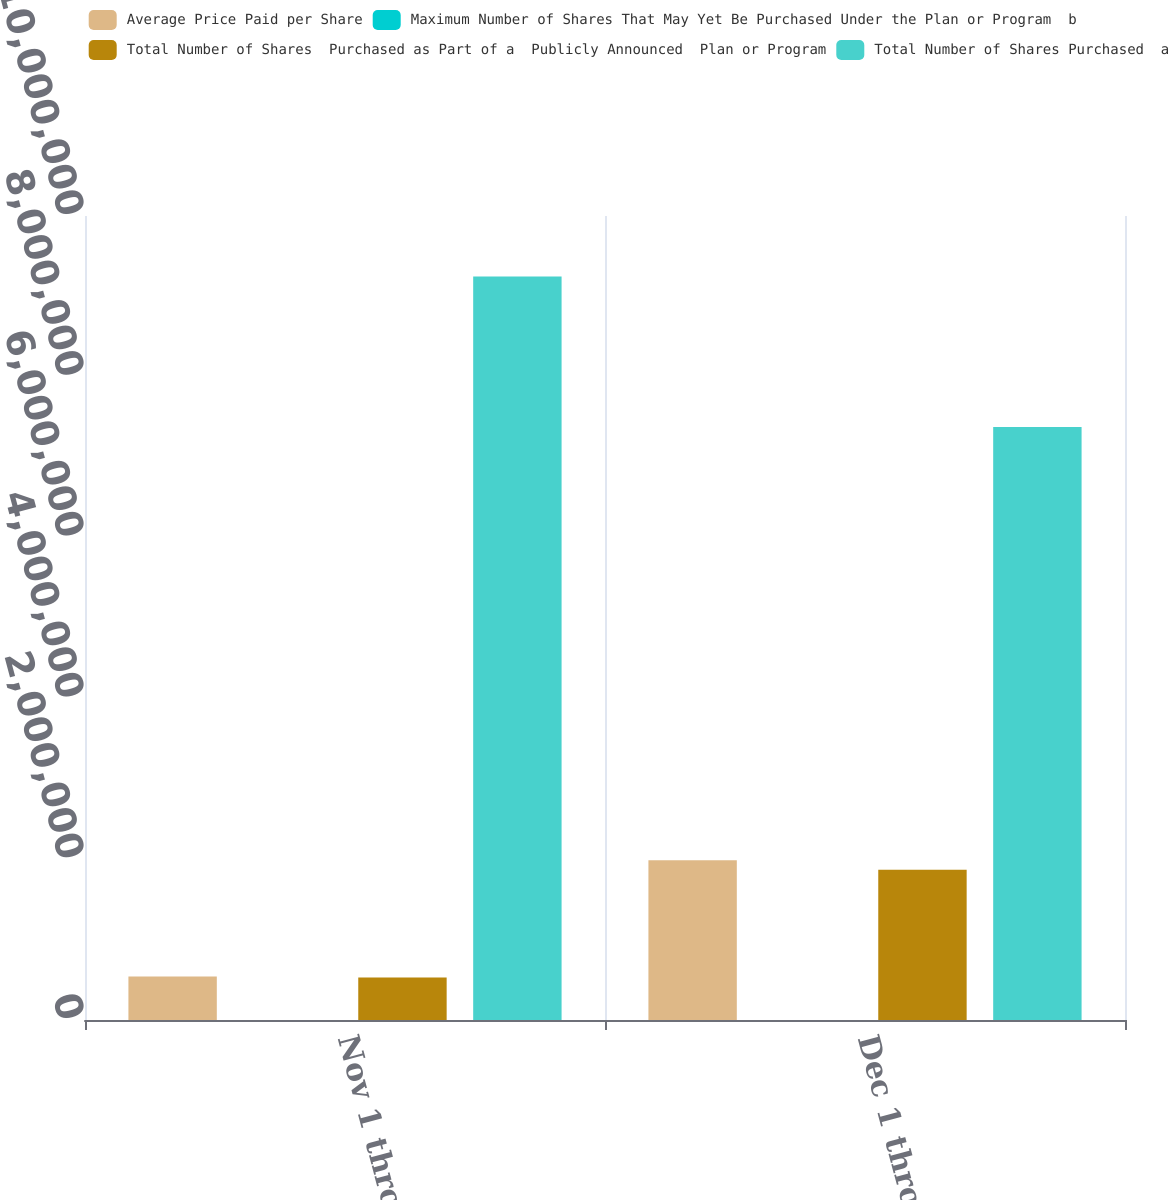Convert chart. <chart><loc_0><loc_0><loc_500><loc_500><stacked_bar_chart><ecel><fcel>Nov 1 through Nov 30<fcel>Dec 1 through Dec 31<nl><fcel>Average Price Paid per Share<fcel>540294<fcel>1.98608e+06<nl><fcel>Maximum Number of Shares That May Yet Be Purchased Under the Plan or Program  b<fcel>124.7<fcel>128.53<nl><fcel>Total Number of Shares  Purchased as Part of a  Publicly Announced  Plan or Program<fcel>528000<fcel>1.8698e+06<nl><fcel>Total Number of Shares Purchased  a<fcel>9.24628e+06<fcel>7.37648e+06<nl></chart> 